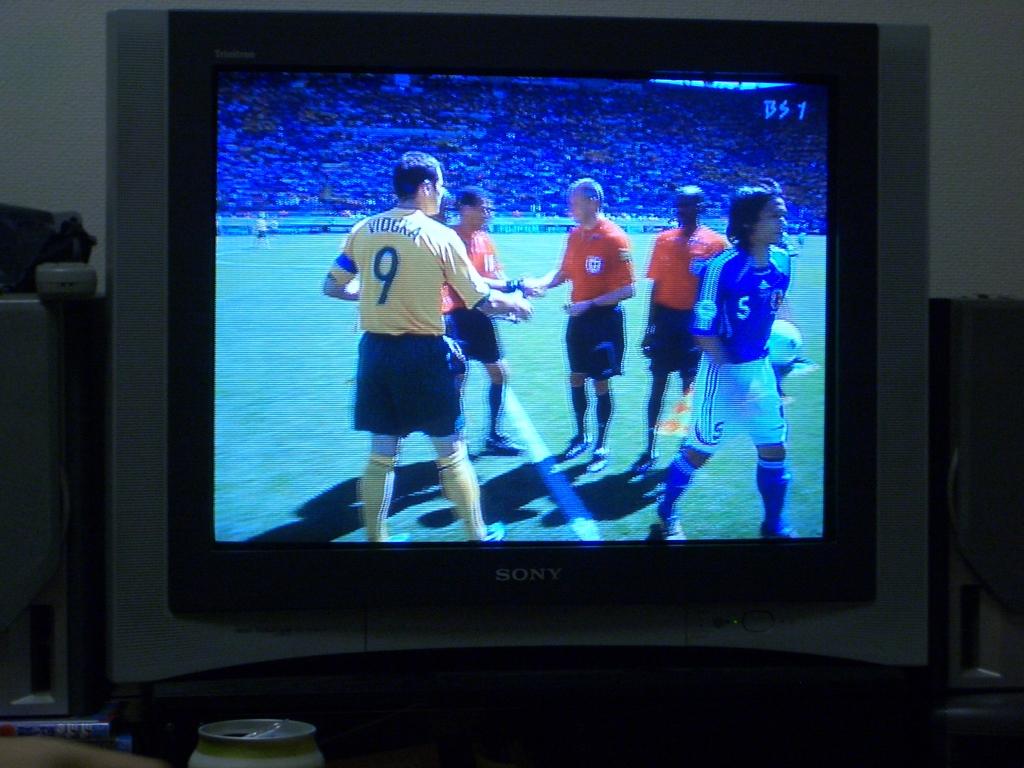What is the jersey number on the left guy?
Offer a terse response. 9. 